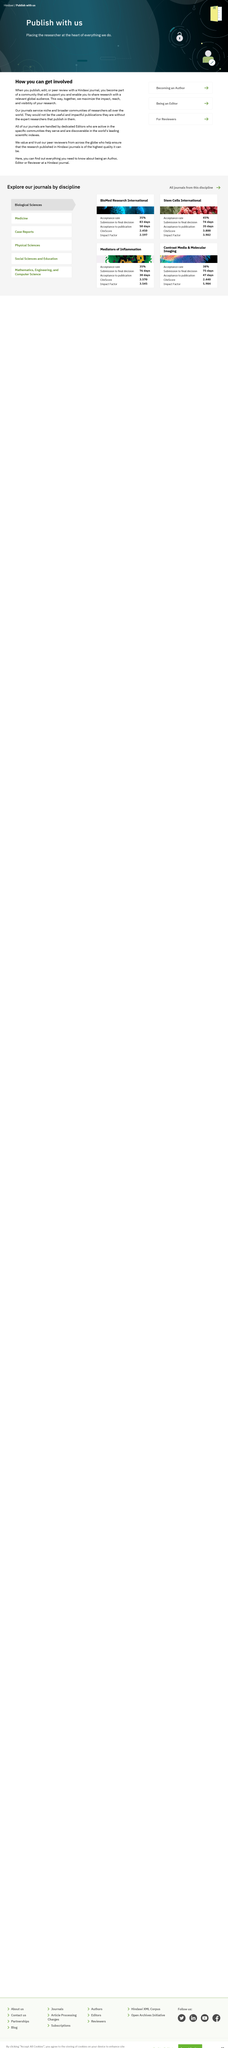Mention a couple of crucial points in this snapshot. Journals provide services to niche and broader communities of researchers from all over the world. By contributing to Hindawi journals, you become a member of a supportive community that enables you to reach a global audience with your research. Journals are managed by dedicated editors who handle them. 